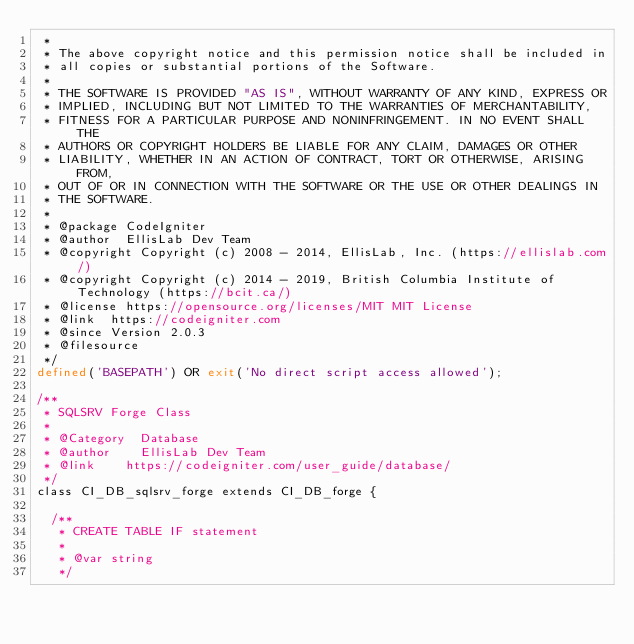<code> <loc_0><loc_0><loc_500><loc_500><_PHP_> *
 * The above copyright notice and this permission notice shall be included in
 * all copies or substantial portions of the Software.
 *
 * THE SOFTWARE IS PROVIDED "AS IS", WITHOUT WARRANTY OF ANY KIND, EXPRESS OR
 * IMPLIED, INCLUDING BUT NOT LIMITED TO THE WARRANTIES OF MERCHANTABILITY,
 * FITNESS FOR A PARTICULAR PURPOSE AND NONINFRINGEMENT. IN NO EVENT SHALL THE
 * AUTHORS OR COPYRIGHT HOLDERS BE LIABLE FOR ANY CLAIM, DAMAGES OR OTHER
 * LIABILITY, WHETHER IN AN ACTION OF CONTRACT, TORT OR OTHERWISE, ARISING FROM,
 * OUT OF OR IN CONNECTION WITH THE SOFTWARE OR THE USE OR OTHER DEALINGS IN
 * THE SOFTWARE.
 *
 * @package	CodeIgniter
 * @author	EllisLab Dev Team
 * @copyright	Copyright (c) 2008 - 2014, EllisLab, Inc. (https://ellislab.com/)
 * @copyright	Copyright (c) 2014 - 2019, British Columbia Institute of Technology (https://bcit.ca/)
 * @license	https://opensource.org/licenses/MIT	MIT License
 * @link	https://codeigniter.com
 * @since	Version 2.0.3
 * @filesource
 */
defined('BASEPATH') OR exit('No direct script access allowed');

/**
 * SQLSRV Forge Class
 *
 * @Category	Database
 * @author		EllisLab Dev Team
 * @link		https://codeigniter.com/user_guide/database/
 */
class CI_DB_sqlsrv_forge extends CI_DB_forge {

	/**
	 * CREATE TABLE IF statement
	 *
	 * @var	string
	 */</code> 